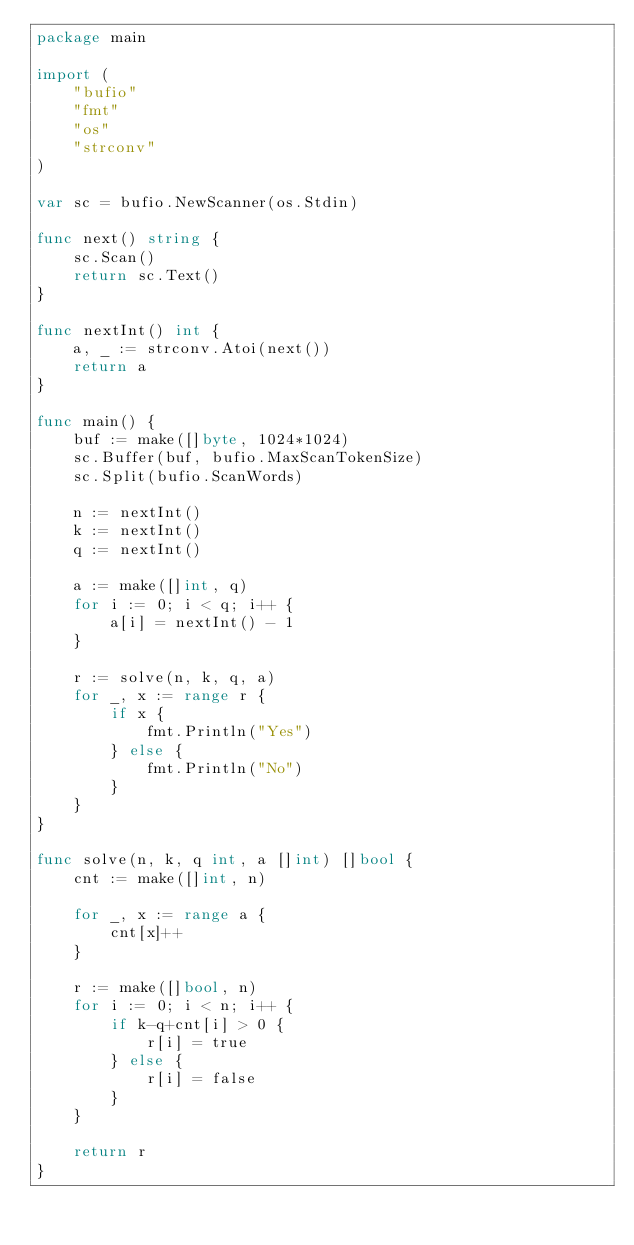Convert code to text. <code><loc_0><loc_0><loc_500><loc_500><_Go_>package main

import (
	"bufio"
	"fmt"
	"os"
	"strconv"
)

var sc = bufio.NewScanner(os.Stdin)

func next() string {
	sc.Scan()
	return sc.Text()
}

func nextInt() int {
	a, _ := strconv.Atoi(next())
	return a
}

func main() {
	buf := make([]byte, 1024*1024)
	sc.Buffer(buf, bufio.MaxScanTokenSize)
	sc.Split(bufio.ScanWords)

	n := nextInt()
	k := nextInt()
	q := nextInt()

	a := make([]int, q)
	for i := 0; i < q; i++ {
		a[i] = nextInt() - 1
	}

	r := solve(n, k, q, a)
	for _, x := range r {
		if x {
			fmt.Println("Yes")
		} else {
			fmt.Println("No")
		}
	}
}

func solve(n, k, q int, a []int) []bool {
	cnt := make([]int, n)

	for _, x := range a {
		cnt[x]++
	}

	r := make([]bool, n)
	for i := 0; i < n; i++ {
		if k-q+cnt[i] > 0 {
			r[i] = true
		} else {
			r[i] = false
		}
	}

	return r
}
</code> 